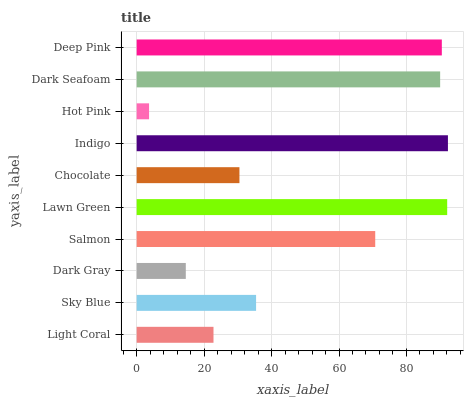Is Hot Pink the minimum?
Answer yes or no. Yes. Is Indigo the maximum?
Answer yes or no. Yes. Is Sky Blue the minimum?
Answer yes or no. No. Is Sky Blue the maximum?
Answer yes or no. No. Is Sky Blue greater than Light Coral?
Answer yes or no. Yes. Is Light Coral less than Sky Blue?
Answer yes or no. Yes. Is Light Coral greater than Sky Blue?
Answer yes or no. No. Is Sky Blue less than Light Coral?
Answer yes or no. No. Is Salmon the high median?
Answer yes or no. Yes. Is Sky Blue the low median?
Answer yes or no. Yes. Is Sky Blue the high median?
Answer yes or no. No. Is Hot Pink the low median?
Answer yes or no. No. 